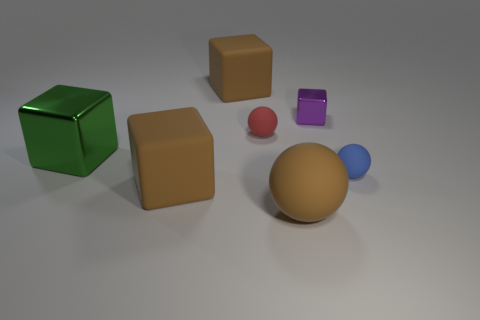Is there anything else that has the same color as the small metal block?
Offer a terse response. No. What is the shape of the thing that is the same material as the big green block?
Keep it short and to the point. Cube. Does the large brown object that is behind the purple metallic thing have the same material as the purple thing?
Offer a very short reply. No. Is the color of the cube that is in front of the small blue matte object the same as the tiny sphere behind the big green shiny cube?
Make the answer very short. No. What number of metal objects are both behind the large metal block and in front of the tiny metal block?
Provide a short and direct response. 0. What is the material of the tiny red thing?
Your response must be concise. Rubber. The shiny object that is the same size as the brown ball is what shape?
Provide a short and direct response. Cube. Does the brown cube that is behind the blue rubber sphere have the same material as the large ball on the right side of the red ball?
Your response must be concise. Yes. What number of cyan shiny cylinders are there?
Keep it short and to the point. 0. What number of green objects are the same shape as the red matte thing?
Ensure brevity in your answer.  0. 